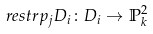Convert formula to latex. <formula><loc_0><loc_0><loc_500><loc_500>\ r e s t r { p _ { j } } { D _ { i } } \colon D _ { i } \to \mathbb { P } _ { k } ^ { 2 }</formula> 